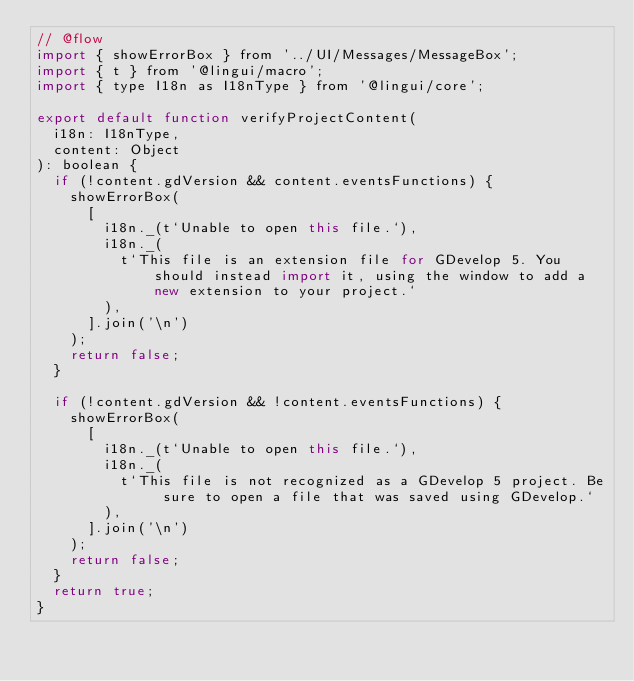Convert code to text. <code><loc_0><loc_0><loc_500><loc_500><_JavaScript_>// @flow
import { showErrorBox } from '../UI/Messages/MessageBox';
import { t } from '@lingui/macro';
import { type I18n as I18nType } from '@lingui/core';

export default function verifyProjectContent(
  i18n: I18nType,
  content: Object
): boolean {
  if (!content.gdVersion && content.eventsFunctions) {
    showErrorBox(
      [
        i18n._(t`Unable to open this file.`),
        i18n._(
          t`This file is an extension file for GDevelop 5. You should instead import it, using the window to add a new extension to your project.`
        ),
      ].join('\n')
    );
    return false;
  }

  if (!content.gdVersion && !content.eventsFunctions) {
    showErrorBox(
      [
        i18n._(t`Unable to open this file.`),
        i18n._(
          t`This file is not recognized as a GDevelop 5 project. Be sure to open a file that was saved using GDevelop.`
        ),
      ].join('\n')
    );
    return false;
  }
  return true;
}
</code> 